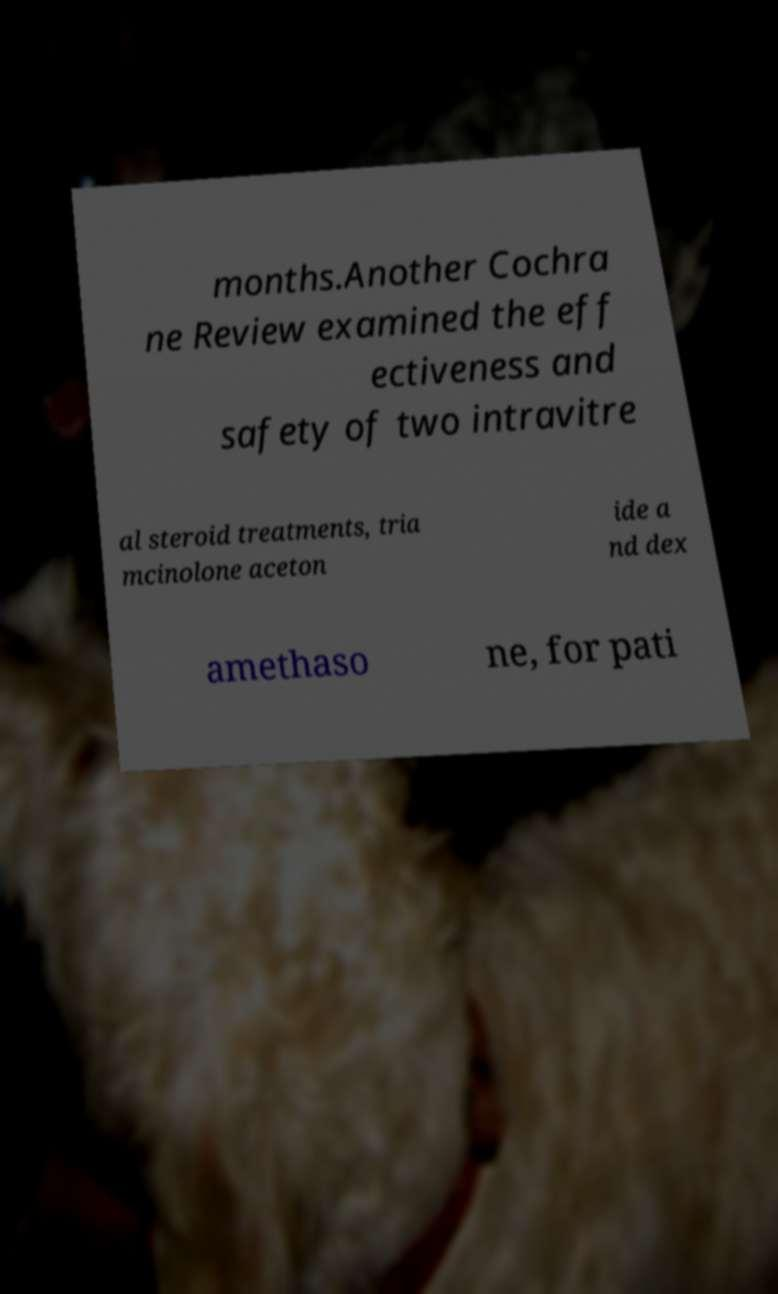Could you assist in decoding the text presented in this image and type it out clearly? months.Another Cochra ne Review examined the eff ectiveness and safety of two intravitre al steroid treatments, tria mcinolone aceton ide a nd dex amethaso ne, for pati 